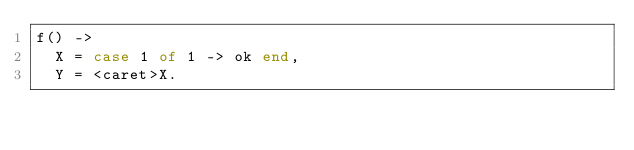<code> <loc_0><loc_0><loc_500><loc_500><_Erlang_>f() ->
  X = case 1 of 1 -> ok end,
  Y = <caret>X.</code> 